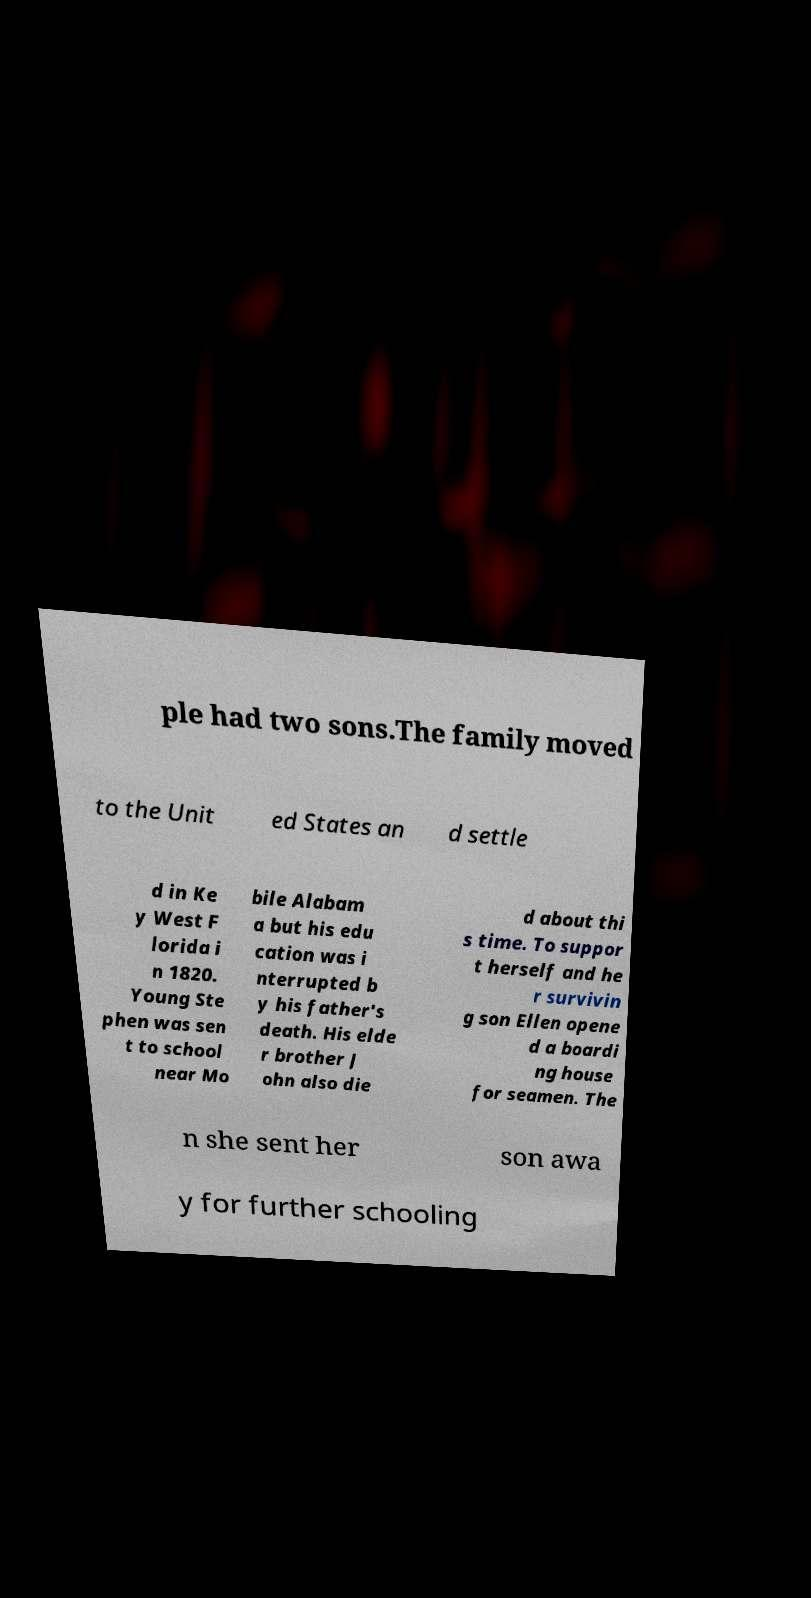Could you assist in decoding the text presented in this image and type it out clearly? ple had two sons.The family moved to the Unit ed States an d settle d in Ke y West F lorida i n 1820. Young Ste phen was sen t to school near Mo bile Alabam a but his edu cation was i nterrupted b y his father's death. His elde r brother J ohn also die d about thi s time. To suppor t herself and he r survivin g son Ellen opene d a boardi ng house for seamen. The n she sent her son awa y for further schooling 